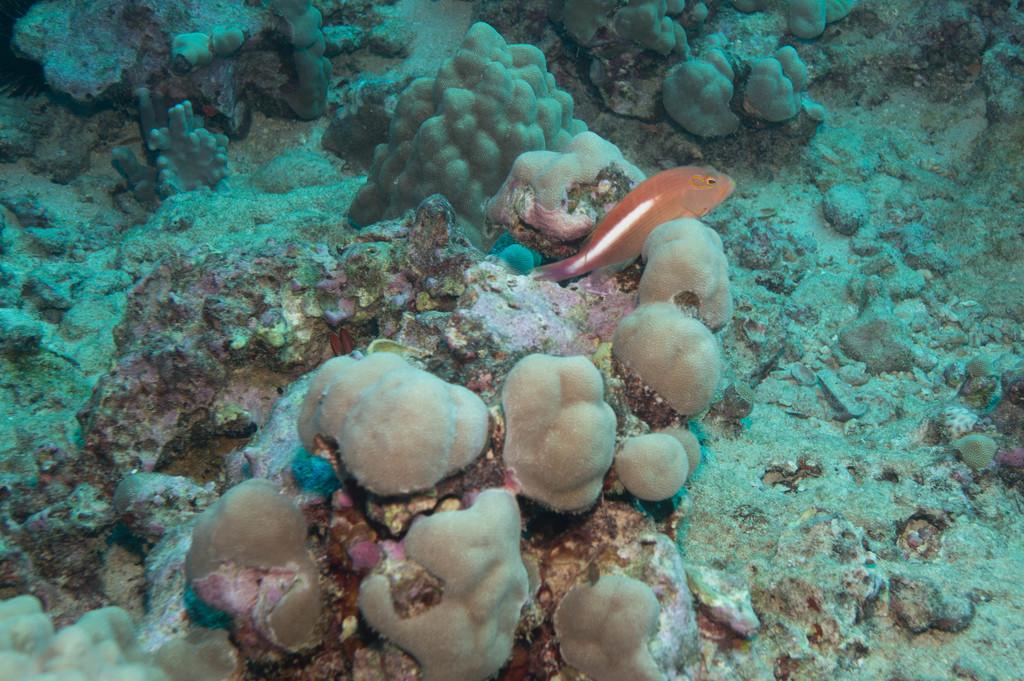What type of environment is depicted in the image? The image shows an underwater scene. What color are the fish in the image? The fish in the image are orange. What are the fish doing in the image? The fish are stuck in corals. How does the toad breathe underwater in the image? There is no toad present in the image; it features orange fish stuck in corals in an underwater scene. 